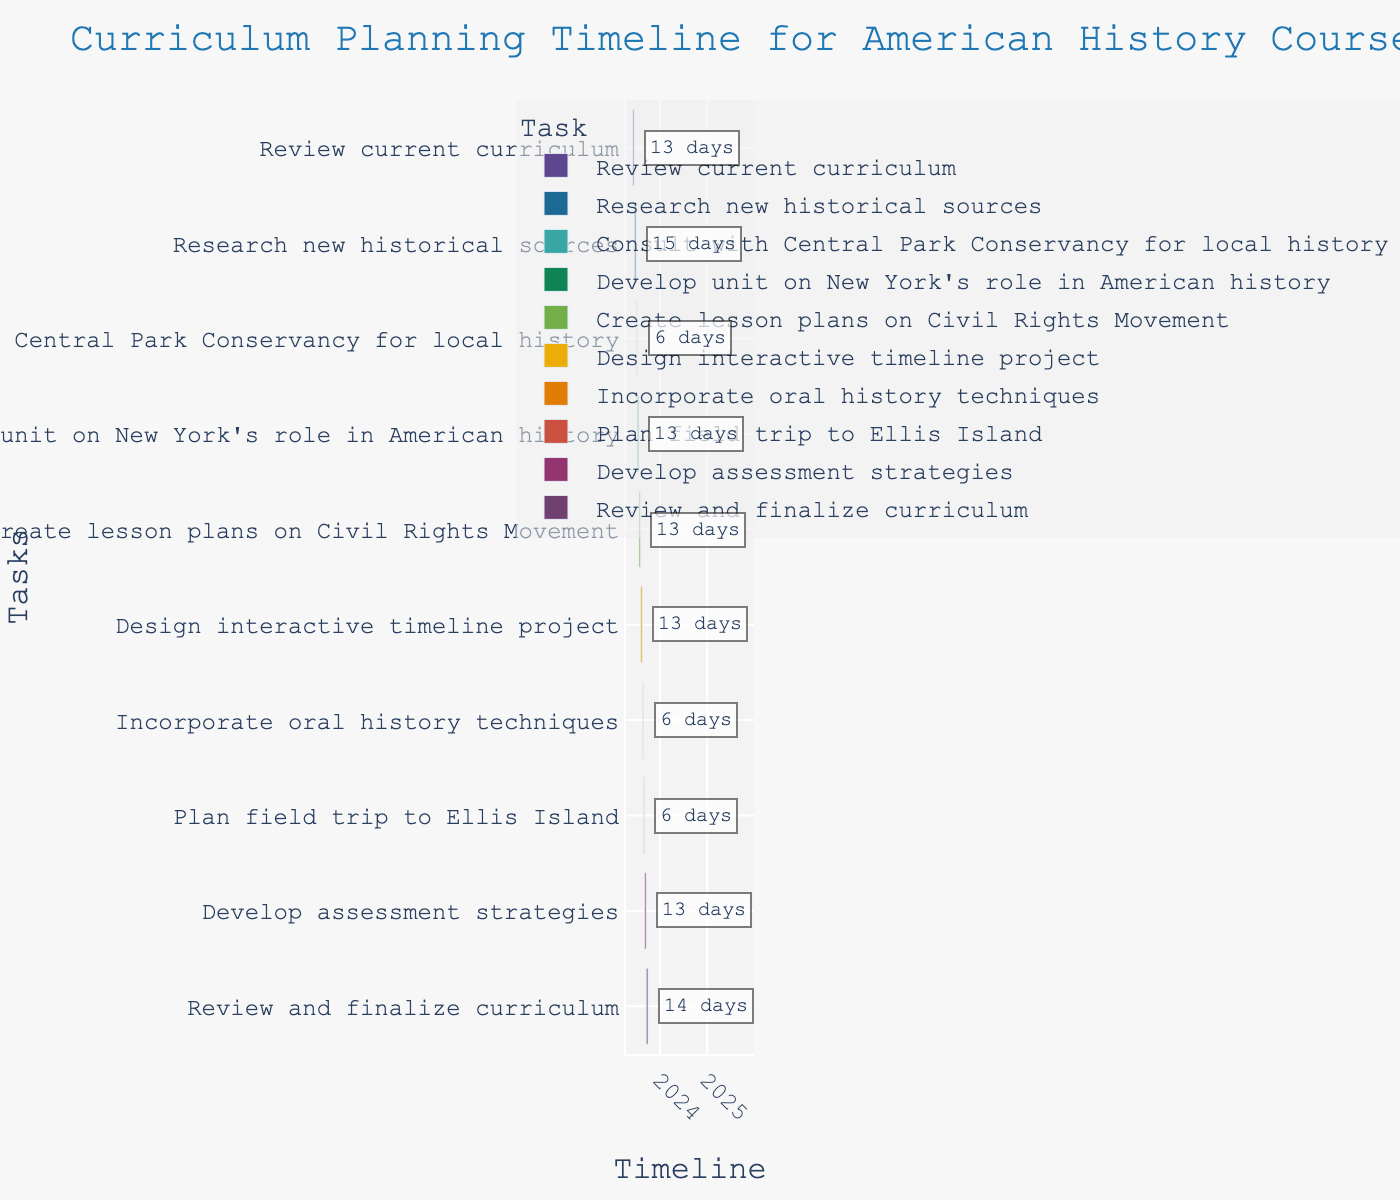What's the title of the Gantt chart? The title is located at the top of the Gantt chart in a larger font size and a different color.
Answer: Curriculum Planning Timeline for American History Course What task starts on July 8, 2023? By observing the starting dates along the timeline axis, you can find that the task "Develop unit on New York's role in American history" starts on July 8, 2023.
Answer: Develop unit on New York's role in American history Which task has the longest duration? By examining the length of each bar representing task durations, "Review and finalize curriculum" is the longest.
Answer: Review and finalize curriculum How many days are allocated to "Design interactive timeline project"? The annotation next to the respective task bar indicates the duration. It shows "13 days" for "Design interactive timeline project".
Answer: 13 days What are the start and end dates for "Consult with Central Park Conservancy for local history"? The task bar corresponding to "Consult with Central Park Conservancy for local history" starts on July 1, 2023, and ends on July 7, 2023.
Answer: July 1, 2023, and July 7, 2023 Which task involves planning a field trip? Through the task names on the y-axis, identify "Plan field trip to Ellis Island" as the task involving a field trip.
Answer: Plan field trip to Ellis Island Which task starts immediately after "Research new historical sources"? By following the chronological order of tasks, you can see that "Consult with Central Park Conservancy for local history" starts right after "Research new historical sources".
Answer: Consult with Central Park Conservancy for local history What is the total number of days allocated for tasks in September 2023? Sum the durations of tasks in September: "Develop assessment strategies" (14 days) and "Review and finalize curriculum" (15 days), totaling 29 days.
Answer: 29 days Which tasks end in August 2023? Look at the bars ending in August 2023 which are "Create lesson plans on Civil Rights Movement" (August 4), "Design interactive timeline project" (August 18), and "Incorporate oral history techniques" (August 25).
Answer: Create lesson plans on Civil Rights Movement, Design interactive timeline project, Incorporate oral history techniques How many tasks are planned for September 2023? Counting the number of tasks on the y-axis that fall within September shows that two tasks are planned.
Answer: 2 tasks 